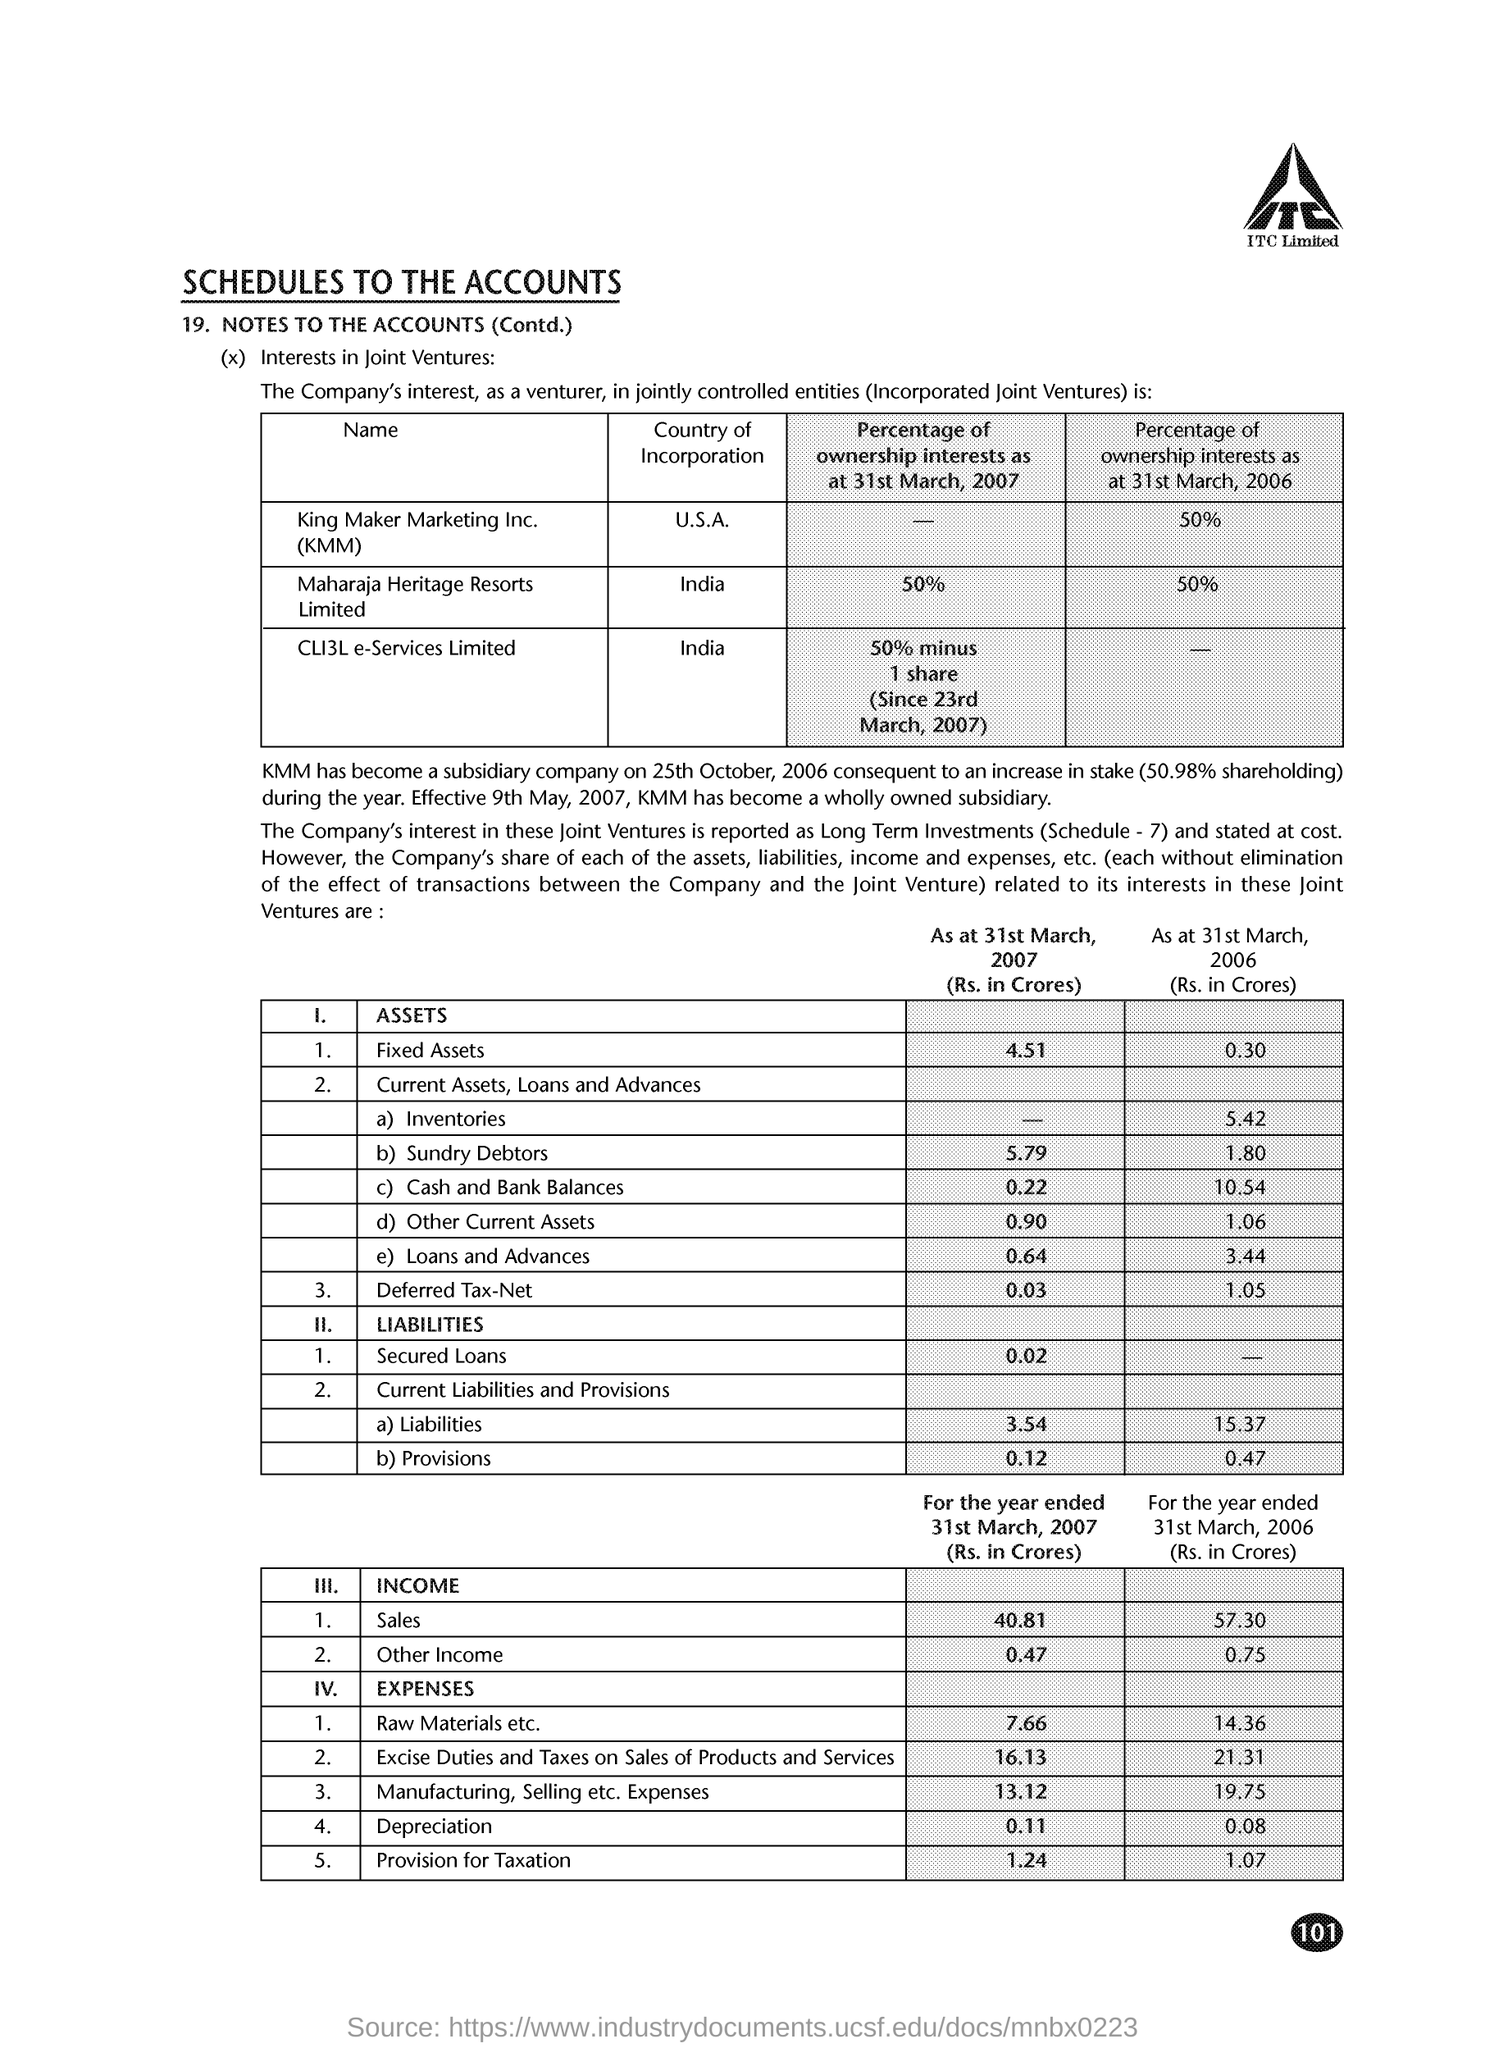Point out several critical features in this image. The total expenses for raw materials and other items for the year ended March 31, 2006 were Rs. 14.36 crores. The fixed assets as at 31st March 2007 were valued at Rs 4.51 crores. The total expenses for raw materials and other items for the year ending March 31, 2007, amounted to 7.66 crores. Maharaja heritage Resorts Limited is incorporated in India. KMM is incorporated in the United States of America. 